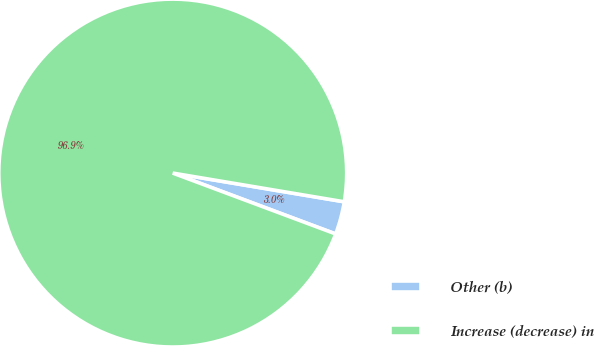Convert chart. <chart><loc_0><loc_0><loc_500><loc_500><pie_chart><fcel>Other (b)<fcel>Increase (decrease) in<nl><fcel>3.05%<fcel>96.95%<nl></chart> 